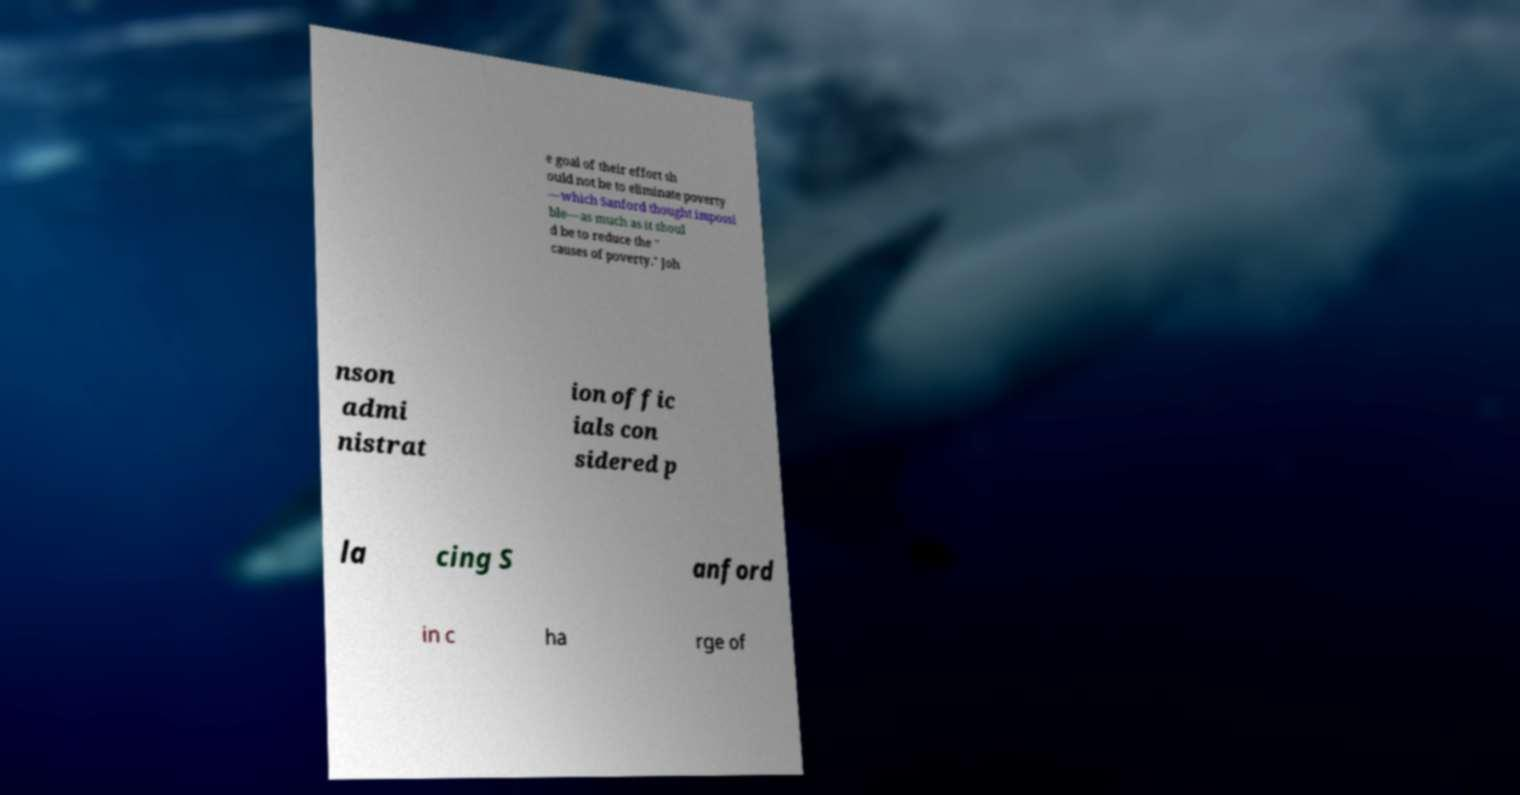Can you read and provide the text displayed in the image?This photo seems to have some interesting text. Can you extract and type it out for me? e goal of their effort sh ould not be to eliminate poverty —which Sanford thought impossi ble—as much as it shoul d be to reduce the " causes of poverty." Joh nson admi nistrat ion offic ials con sidered p la cing S anford in c ha rge of 